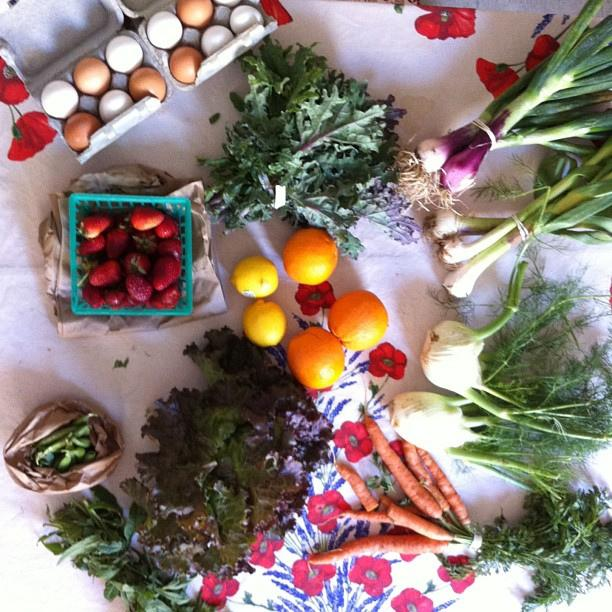What is the orange item near the bottom of the pile?

Choices:
A) garfield doll
B) lime
C) carrot
D) thumb tack carrot 